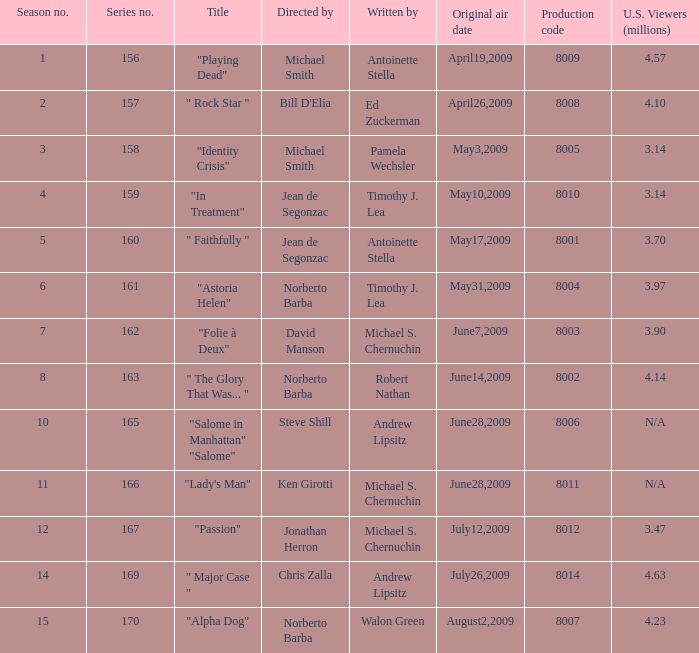What is the largest production code? 8014.0. 